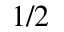<formula> <loc_0><loc_0><loc_500><loc_500>1 / 2</formula> 